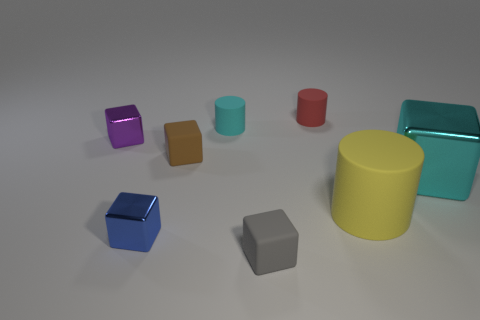Is the material of the brown object the same as the yellow cylinder?
Ensure brevity in your answer.  Yes. There is a brown rubber cube; are there any gray rubber blocks on the left side of it?
Provide a succinct answer. No. The cyan thing in front of the small cube to the left of the blue thing is made of what material?
Provide a short and direct response. Metal. There is a yellow thing that is the same shape as the tiny red rubber thing; what size is it?
Keep it short and to the point. Large. Is the big cylinder the same color as the large metallic cube?
Provide a succinct answer. No. What is the color of the shiny cube that is both to the left of the large yellow cylinder and right of the tiny purple thing?
Your answer should be very brief. Blue. Do the cyan thing behind the purple block and the big yellow cylinder have the same size?
Offer a very short reply. No. Is the material of the tiny purple cube the same as the cyan thing that is right of the small cyan object?
Your answer should be very brief. Yes. What number of cyan objects are large things or large metal cubes?
Offer a terse response. 1. Are any cyan rubber spheres visible?
Your answer should be compact. No. 